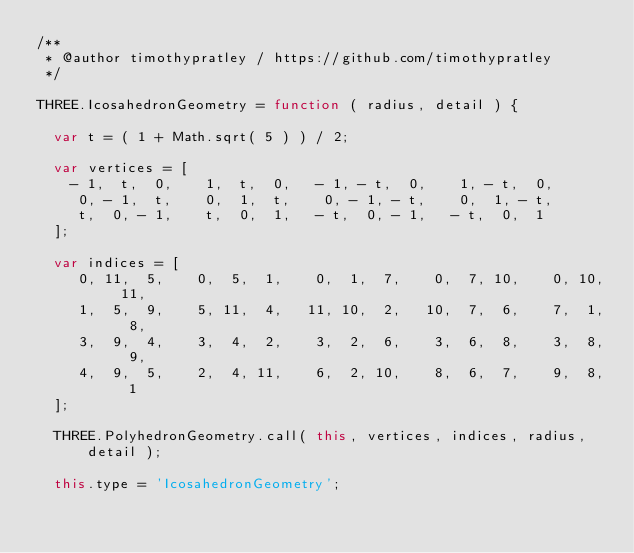Convert code to text. <code><loc_0><loc_0><loc_500><loc_500><_JavaScript_>/**
 * @author timothypratley / https://github.com/timothypratley
 */

THREE.IcosahedronGeometry = function ( radius, detail ) {

	var t = ( 1 + Math.sqrt( 5 ) ) / 2;

	var vertices = [
		- 1,  t,  0,    1,  t,  0,   - 1, - t,  0,    1, - t,  0,
		 0, - 1,  t,    0,  1,  t,    0, - 1, - t,    0,  1, - t,
		 t,  0, - 1,    t,  0,  1,   - t,  0, - 1,   - t,  0,  1
	];

	var indices = [
		 0, 11,  5,    0,  5,  1,    0,  1,  7,    0,  7, 10,    0, 10, 11,
		 1,  5,  9,    5, 11,  4,   11, 10,  2,   10,  7,  6,    7,  1,  8,
		 3,  9,  4,    3,  4,  2,    3,  2,  6,    3,  6,  8,    3,  8,  9,
		 4,  9,  5,    2,  4, 11,    6,  2, 10,    8,  6,  7,    9,  8,  1
	];

	THREE.PolyhedronGeometry.call( this, vertices, indices, radius, detail );

	this.type = 'IcosahedronGeometry';
</code> 